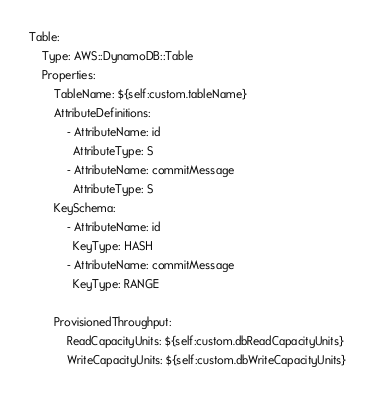Convert code to text. <code><loc_0><loc_0><loc_500><loc_500><_YAML_>Table:
    Type: AWS::DynamoDB::Table
    Properties:
        TableName: ${self:custom.tableName}
        AttributeDefinitions:
            - AttributeName: id
              AttributeType: S
            - AttributeName: commitMessage
              AttributeType: S
        KeySchema:
            - AttributeName: id
              KeyType: HASH
            - AttributeName: commitMessage
              KeyType: RANGE
        
        ProvisionedThroughput:
            ReadCapacityUnits: ${self:custom.dbReadCapacityUnits}
            WriteCapacityUnits: ${self:custom.dbWriteCapacityUnits}</code> 